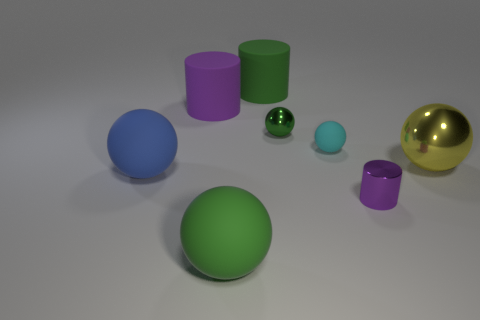Subtract 2 spheres. How many spheres are left? 3 Subtract all green balls. How many balls are left? 3 Subtract all shiny balls. How many balls are left? 3 Subtract all red spheres. Subtract all purple cubes. How many spheres are left? 5 Add 1 big cylinders. How many objects exist? 9 Subtract all balls. How many objects are left? 3 Add 2 tiny cyan spheres. How many tiny cyan spheres exist? 3 Subtract 0 brown cylinders. How many objects are left? 8 Subtract all big green rubber cylinders. Subtract all shiny cylinders. How many objects are left? 6 Add 5 large cylinders. How many large cylinders are left? 7 